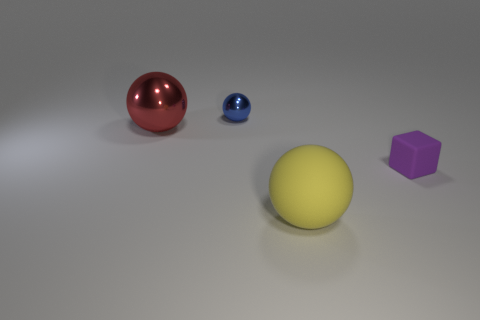Is the number of small shiny spheres left of the large red shiny thing the same as the number of big metallic spheres?
Offer a terse response. No. How many objects are both on the right side of the large red metallic ball and on the left side of the rubber ball?
Ensure brevity in your answer.  1. There is a matte thing that is the same shape as the blue shiny thing; what size is it?
Make the answer very short. Large. What number of large yellow things have the same material as the tiny sphere?
Make the answer very short. 0. Is the number of large rubber spheres that are behind the red ball less than the number of big red rubber blocks?
Give a very brief answer. No. How many green blocks are there?
Provide a succinct answer. 0. What number of blocks have the same color as the large matte sphere?
Give a very brief answer. 0. Is the purple object the same shape as the blue metal thing?
Provide a succinct answer. No. What size is the rubber object that is in front of the tiny object that is in front of the blue thing?
Your response must be concise. Large. Are there any other blue metal things of the same size as the blue object?
Keep it short and to the point. No. 